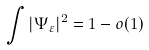<formula> <loc_0><loc_0><loc_500><loc_500>\int | \Psi _ { \varepsilon } | ^ { 2 } = 1 - o ( 1 )</formula> 